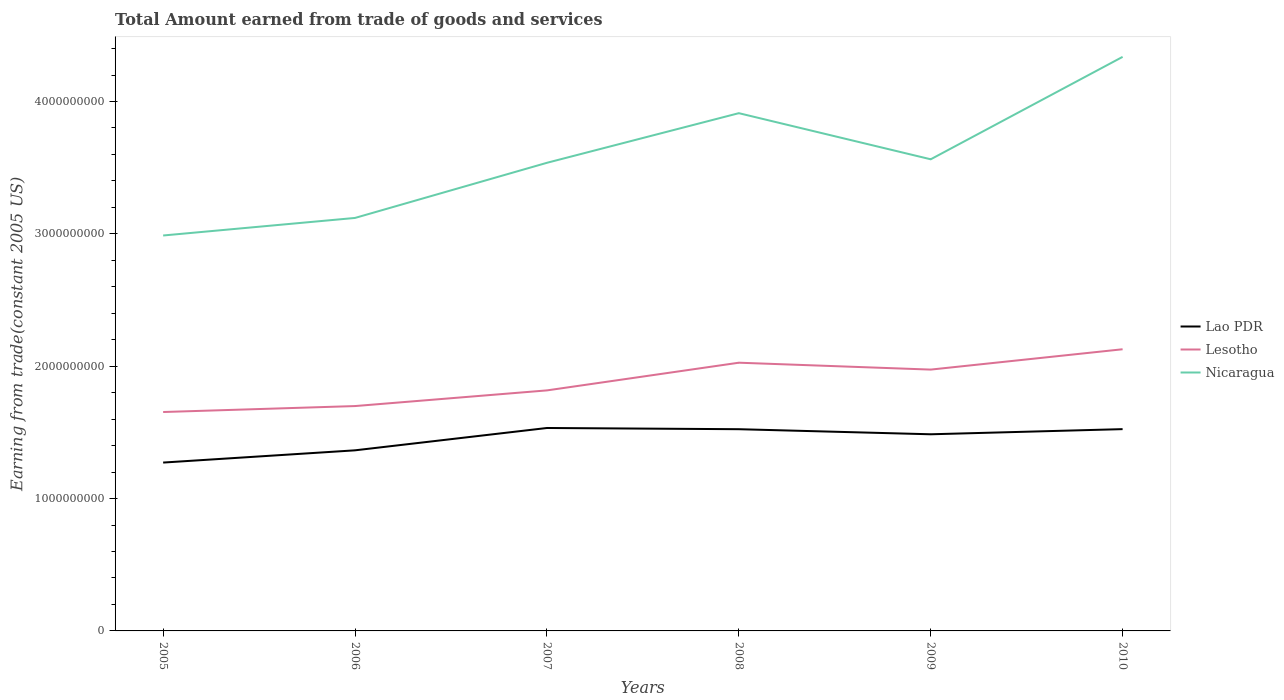Does the line corresponding to Lao PDR intersect with the line corresponding to Lesotho?
Your response must be concise. No. Across all years, what is the maximum total amount earned by trading goods and services in Lao PDR?
Your response must be concise. 1.27e+09. In which year was the total amount earned by trading goods and services in Nicaragua maximum?
Offer a terse response. 2005. What is the total total amount earned by trading goods and services in Nicaragua in the graph?
Provide a succinct answer. -9.24e+08. What is the difference between the highest and the second highest total amount earned by trading goods and services in Lao PDR?
Your response must be concise. 2.61e+08. What is the difference between the highest and the lowest total amount earned by trading goods and services in Lesotho?
Offer a terse response. 3. How many lines are there?
Offer a terse response. 3. What is the difference between two consecutive major ticks on the Y-axis?
Your response must be concise. 1.00e+09. Are the values on the major ticks of Y-axis written in scientific E-notation?
Ensure brevity in your answer.  No. Does the graph contain grids?
Your answer should be very brief. No. How are the legend labels stacked?
Your answer should be compact. Vertical. What is the title of the graph?
Offer a terse response. Total Amount earned from trade of goods and services. Does "Kenya" appear as one of the legend labels in the graph?
Your answer should be very brief. No. What is the label or title of the Y-axis?
Offer a very short reply. Earning from trade(constant 2005 US). What is the Earning from trade(constant 2005 US) in Lao PDR in 2005?
Provide a succinct answer. 1.27e+09. What is the Earning from trade(constant 2005 US) in Lesotho in 2005?
Offer a terse response. 1.65e+09. What is the Earning from trade(constant 2005 US) in Nicaragua in 2005?
Keep it short and to the point. 2.99e+09. What is the Earning from trade(constant 2005 US) of Lao PDR in 2006?
Your response must be concise. 1.36e+09. What is the Earning from trade(constant 2005 US) of Lesotho in 2006?
Your response must be concise. 1.70e+09. What is the Earning from trade(constant 2005 US) of Nicaragua in 2006?
Keep it short and to the point. 3.12e+09. What is the Earning from trade(constant 2005 US) of Lao PDR in 2007?
Your response must be concise. 1.53e+09. What is the Earning from trade(constant 2005 US) in Lesotho in 2007?
Offer a very short reply. 1.82e+09. What is the Earning from trade(constant 2005 US) in Nicaragua in 2007?
Make the answer very short. 3.54e+09. What is the Earning from trade(constant 2005 US) of Lao PDR in 2008?
Ensure brevity in your answer.  1.52e+09. What is the Earning from trade(constant 2005 US) of Lesotho in 2008?
Keep it short and to the point. 2.03e+09. What is the Earning from trade(constant 2005 US) of Nicaragua in 2008?
Give a very brief answer. 3.91e+09. What is the Earning from trade(constant 2005 US) of Lao PDR in 2009?
Your answer should be compact. 1.49e+09. What is the Earning from trade(constant 2005 US) in Lesotho in 2009?
Offer a very short reply. 1.97e+09. What is the Earning from trade(constant 2005 US) in Nicaragua in 2009?
Keep it short and to the point. 3.56e+09. What is the Earning from trade(constant 2005 US) in Lao PDR in 2010?
Your response must be concise. 1.52e+09. What is the Earning from trade(constant 2005 US) of Lesotho in 2010?
Offer a terse response. 2.13e+09. What is the Earning from trade(constant 2005 US) of Nicaragua in 2010?
Offer a very short reply. 4.34e+09. Across all years, what is the maximum Earning from trade(constant 2005 US) of Lao PDR?
Provide a succinct answer. 1.53e+09. Across all years, what is the maximum Earning from trade(constant 2005 US) of Lesotho?
Give a very brief answer. 2.13e+09. Across all years, what is the maximum Earning from trade(constant 2005 US) of Nicaragua?
Give a very brief answer. 4.34e+09. Across all years, what is the minimum Earning from trade(constant 2005 US) of Lao PDR?
Your answer should be compact. 1.27e+09. Across all years, what is the minimum Earning from trade(constant 2005 US) in Lesotho?
Make the answer very short. 1.65e+09. Across all years, what is the minimum Earning from trade(constant 2005 US) of Nicaragua?
Provide a succinct answer. 2.99e+09. What is the total Earning from trade(constant 2005 US) in Lao PDR in the graph?
Ensure brevity in your answer.  8.70e+09. What is the total Earning from trade(constant 2005 US) in Lesotho in the graph?
Offer a terse response. 1.13e+1. What is the total Earning from trade(constant 2005 US) in Nicaragua in the graph?
Make the answer very short. 2.15e+1. What is the difference between the Earning from trade(constant 2005 US) in Lao PDR in 2005 and that in 2006?
Provide a short and direct response. -9.25e+07. What is the difference between the Earning from trade(constant 2005 US) in Lesotho in 2005 and that in 2006?
Your answer should be compact. -4.50e+07. What is the difference between the Earning from trade(constant 2005 US) of Nicaragua in 2005 and that in 2006?
Keep it short and to the point. -1.33e+08. What is the difference between the Earning from trade(constant 2005 US) of Lao PDR in 2005 and that in 2007?
Give a very brief answer. -2.61e+08. What is the difference between the Earning from trade(constant 2005 US) in Lesotho in 2005 and that in 2007?
Provide a succinct answer. -1.63e+08. What is the difference between the Earning from trade(constant 2005 US) in Nicaragua in 2005 and that in 2007?
Offer a very short reply. -5.49e+08. What is the difference between the Earning from trade(constant 2005 US) in Lao PDR in 2005 and that in 2008?
Provide a succinct answer. -2.52e+08. What is the difference between the Earning from trade(constant 2005 US) in Lesotho in 2005 and that in 2008?
Provide a short and direct response. -3.73e+08. What is the difference between the Earning from trade(constant 2005 US) in Nicaragua in 2005 and that in 2008?
Your answer should be very brief. -9.24e+08. What is the difference between the Earning from trade(constant 2005 US) of Lao PDR in 2005 and that in 2009?
Ensure brevity in your answer.  -2.14e+08. What is the difference between the Earning from trade(constant 2005 US) in Lesotho in 2005 and that in 2009?
Your answer should be compact. -3.20e+08. What is the difference between the Earning from trade(constant 2005 US) of Nicaragua in 2005 and that in 2009?
Give a very brief answer. -5.76e+08. What is the difference between the Earning from trade(constant 2005 US) in Lao PDR in 2005 and that in 2010?
Make the answer very short. -2.53e+08. What is the difference between the Earning from trade(constant 2005 US) in Lesotho in 2005 and that in 2010?
Offer a very short reply. -4.74e+08. What is the difference between the Earning from trade(constant 2005 US) of Nicaragua in 2005 and that in 2010?
Offer a very short reply. -1.35e+09. What is the difference between the Earning from trade(constant 2005 US) in Lao PDR in 2006 and that in 2007?
Give a very brief answer. -1.69e+08. What is the difference between the Earning from trade(constant 2005 US) in Lesotho in 2006 and that in 2007?
Provide a short and direct response. -1.18e+08. What is the difference between the Earning from trade(constant 2005 US) of Nicaragua in 2006 and that in 2007?
Ensure brevity in your answer.  -4.17e+08. What is the difference between the Earning from trade(constant 2005 US) of Lao PDR in 2006 and that in 2008?
Provide a short and direct response. -1.60e+08. What is the difference between the Earning from trade(constant 2005 US) in Lesotho in 2006 and that in 2008?
Your answer should be compact. -3.28e+08. What is the difference between the Earning from trade(constant 2005 US) of Nicaragua in 2006 and that in 2008?
Give a very brief answer. -7.92e+08. What is the difference between the Earning from trade(constant 2005 US) in Lao PDR in 2006 and that in 2009?
Offer a very short reply. -1.21e+08. What is the difference between the Earning from trade(constant 2005 US) of Lesotho in 2006 and that in 2009?
Offer a terse response. -2.76e+08. What is the difference between the Earning from trade(constant 2005 US) of Nicaragua in 2006 and that in 2009?
Your answer should be very brief. -4.43e+08. What is the difference between the Earning from trade(constant 2005 US) of Lao PDR in 2006 and that in 2010?
Give a very brief answer. -1.60e+08. What is the difference between the Earning from trade(constant 2005 US) in Lesotho in 2006 and that in 2010?
Make the answer very short. -4.29e+08. What is the difference between the Earning from trade(constant 2005 US) in Nicaragua in 2006 and that in 2010?
Provide a short and direct response. -1.22e+09. What is the difference between the Earning from trade(constant 2005 US) of Lao PDR in 2007 and that in 2008?
Ensure brevity in your answer.  9.15e+06. What is the difference between the Earning from trade(constant 2005 US) of Lesotho in 2007 and that in 2008?
Keep it short and to the point. -2.09e+08. What is the difference between the Earning from trade(constant 2005 US) of Nicaragua in 2007 and that in 2008?
Your answer should be very brief. -3.75e+08. What is the difference between the Earning from trade(constant 2005 US) in Lao PDR in 2007 and that in 2009?
Offer a very short reply. 4.75e+07. What is the difference between the Earning from trade(constant 2005 US) of Lesotho in 2007 and that in 2009?
Provide a succinct answer. -1.57e+08. What is the difference between the Earning from trade(constant 2005 US) of Nicaragua in 2007 and that in 2009?
Provide a short and direct response. -2.65e+07. What is the difference between the Earning from trade(constant 2005 US) in Lao PDR in 2007 and that in 2010?
Provide a succinct answer. 8.63e+06. What is the difference between the Earning from trade(constant 2005 US) of Lesotho in 2007 and that in 2010?
Your answer should be compact. -3.11e+08. What is the difference between the Earning from trade(constant 2005 US) of Nicaragua in 2007 and that in 2010?
Your answer should be very brief. -8.00e+08. What is the difference between the Earning from trade(constant 2005 US) of Lao PDR in 2008 and that in 2009?
Your response must be concise. 3.84e+07. What is the difference between the Earning from trade(constant 2005 US) of Lesotho in 2008 and that in 2009?
Provide a succinct answer. 5.20e+07. What is the difference between the Earning from trade(constant 2005 US) of Nicaragua in 2008 and that in 2009?
Give a very brief answer. 3.48e+08. What is the difference between the Earning from trade(constant 2005 US) of Lao PDR in 2008 and that in 2010?
Give a very brief answer. -5.24e+05. What is the difference between the Earning from trade(constant 2005 US) in Lesotho in 2008 and that in 2010?
Give a very brief answer. -1.02e+08. What is the difference between the Earning from trade(constant 2005 US) in Nicaragua in 2008 and that in 2010?
Make the answer very short. -4.25e+08. What is the difference between the Earning from trade(constant 2005 US) of Lao PDR in 2009 and that in 2010?
Your answer should be compact. -3.89e+07. What is the difference between the Earning from trade(constant 2005 US) in Lesotho in 2009 and that in 2010?
Ensure brevity in your answer.  -1.54e+08. What is the difference between the Earning from trade(constant 2005 US) of Nicaragua in 2009 and that in 2010?
Keep it short and to the point. -7.74e+08. What is the difference between the Earning from trade(constant 2005 US) in Lao PDR in 2005 and the Earning from trade(constant 2005 US) in Lesotho in 2006?
Provide a short and direct response. -4.27e+08. What is the difference between the Earning from trade(constant 2005 US) in Lao PDR in 2005 and the Earning from trade(constant 2005 US) in Nicaragua in 2006?
Offer a terse response. -1.85e+09. What is the difference between the Earning from trade(constant 2005 US) in Lesotho in 2005 and the Earning from trade(constant 2005 US) in Nicaragua in 2006?
Give a very brief answer. -1.47e+09. What is the difference between the Earning from trade(constant 2005 US) of Lao PDR in 2005 and the Earning from trade(constant 2005 US) of Lesotho in 2007?
Offer a terse response. -5.45e+08. What is the difference between the Earning from trade(constant 2005 US) in Lao PDR in 2005 and the Earning from trade(constant 2005 US) in Nicaragua in 2007?
Make the answer very short. -2.26e+09. What is the difference between the Earning from trade(constant 2005 US) of Lesotho in 2005 and the Earning from trade(constant 2005 US) of Nicaragua in 2007?
Ensure brevity in your answer.  -1.88e+09. What is the difference between the Earning from trade(constant 2005 US) of Lao PDR in 2005 and the Earning from trade(constant 2005 US) of Lesotho in 2008?
Provide a short and direct response. -7.54e+08. What is the difference between the Earning from trade(constant 2005 US) of Lao PDR in 2005 and the Earning from trade(constant 2005 US) of Nicaragua in 2008?
Your answer should be compact. -2.64e+09. What is the difference between the Earning from trade(constant 2005 US) of Lesotho in 2005 and the Earning from trade(constant 2005 US) of Nicaragua in 2008?
Give a very brief answer. -2.26e+09. What is the difference between the Earning from trade(constant 2005 US) of Lao PDR in 2005 and the Earning from trade(constant 2005 US) of Lesotho in 2009?
Give a very brief answer. -7.02e+08. What is the difference between the Earning from trade(constant 2005 US) in Lao PDR in 2005 and the Earning from trade(constant 2005 US) in Nicaragua in 2009?
Your response must be concise. -2.29e+09. What is the difference between the Earning from trade(constant 2005 US) in Lesotho in 2005 and the Earning from trade(constant 2005 US) in Nicaragua in 2009?
Your answer should be very brief. -1.91e+09. What is the difference between the Earning from trade(constant 2005 US) in Lao PDR in 2005 and the Earning from trade(constant 2005 US) in Lesotho in 2010?
Your response must be concise. -8.56e+08. What is the difference between the Earning from trade(constant 2005 US) in Lao PDR in 2005 and the Earning from trade(constant 2005 US) in Nicaragua in 2010?
Your response must be concise. -3.07e+09. What is the difference between the Earning from trade(constant 2005 US) of Lesotho in 2005 and the Earning from trade(constant 2005 US) of Nicaragua in 2010?
Make the answer very short. -2.68e+09. What is the difference between the Earning from trade(constant 2005 US) in Lao PDR in 2006 and the Earning from trade(constant 2005 US) in Lesotho in 2007?
Provide a succinct answer. -4.53e+08. What is the difference between the Earning from trade(constant 2005 US) in Lao PDR in 2006 and the Earning from trade(constant 2005 US) in Nicaragua in 2007?
Offer a very short reply. -2.17e+09. What is the difference between the Earning from trade(constant 2005 US) in Lesotho in 2006 and the Earning from trade(constant 2005 US) in Nicaragua in 2007?
Provide a short and direct response. -1.84e+09. What is the difference between the Earning from trade(constant 2005 US) of Lao PDR in 2006 and the Earning from trade(constant 2005 US) of Lesotho in 2008?
Your answer should be compact. -6.62e+08. What is the difference between the Earning from trade(constant 2005 US) in Lao PDR in 2006 and the Earning from trade(constant 2005 US) in Nicaragua in 2008?
Your answer should be compact. -2.55e+09. What is the difference between the Earning from trade(constant 2005 US) of Lesotho in 2006 and the Earning from trade(constant 2005 US) of Nicaragua in 2008?
Ensure brevity in your answer.  -2.21e+09. What is the difference between the Earning from trade(constant 2005 US) of Lao PDR in 2006 and the Earning from trade(constant 2005 US) of Lesotho in 2009?
Give a very brief answer. -6.10e+08. What is the difference between the Earning from trade(constant 2005 US) in Lao PDR in 2006 and the Earning from trade(constant 2005 US) in Nicaragua in 2009?
Provide a succinct answer. -2.20e+09. What is the difference between the Earning from trade(constant 2005 US) of Lesotho in 2006 and the Earning from trade(constant 2005 US) of Nicaragua in 2009?
Your response must be concise. -1.86e+09. What is the difference between the Earning from trade(constant 2005 US) in Lao PDR in 2006 and the Earning from trade(constant 2005 US) in Lesotho in 2010?
Keep it short and to the point. -7.64e+08. What is the difference between the Earning from trade(constant 2005 US) of Lao PDR in 2006 and the Earning from trade(constant 2005 US) of Nicaragua in 2010?
Offer a very short reply. -2.97e+09. What is the difference between the Earning from trade(constant 2005 US) of Lesotho in 2006 and the Earning from trade(constant 2005 US) of Nicaragua in 2010?
Keep it short and to the point. -2.64e+09. What is the difference between the Earning from trade(constant 2005 US) of Lao PDR in 2007 and the Earning from trade(constant 2005 US) of Lesotho in 2008?
Make the answer very short. -4.93e+08. What is the difference between the Earning from trade(constant 2005 US) in Lao PDR in 2007 and the Earning from trade(constant 2005 US) in Nicaragua in 2008?
Your answer should be very brief. -2.38e+09. What is the difference between the Earning from trade(constant 2005 US) of Lesotho in 2007 and the Earning from trade(constant 2005 US) of Nicaragua in 2008?
Offer a terse response. -2.09e+09. What is the difference between the Earning from trade(constant 2005 US) of Lao PDR in 2007 and the Earning from trade(constant 2005 US) of Lesotho in 2009?
Provide a short and direct response. -4.41e+08. What is the difference between the Earning from trade(constant 2005 US) in Lao PDR in 2007 and the Earning from trade(constant 2005 US) in Nicaragua in 2009?
Offer a terse response. -2.03e+09. What is the difference between the Earning from trade(constant 2005 US) of Lesotho in 2007 and the Earning from trade(constant 2005 US) of Nicaragua in 2009?
Your answer should be compact. -1.75e+09. What is the difference between the Earning from trade(constant 2005 US) in Lao PDR in 2007 and the Earning from trade(constant 2005 US) in Lesotho in 2010?
Give a very brief answer. -5.95e+08. What is the difference between the Earning from trade(constant 2005 US) of Lao PDR in 2007 and the Earning from trade(constant 2005 US) of Nicaragua in 2010?
Offer a very short reply. -2.80e+09. What is the difference between the Earning from trade(constant 2005 US) of Lesotho in 2007 and the Earning from trade(constant 2005 US) of Nicaragua in 2010?
Keep it short and to the point. -2.52e+09. What is the difference between the Earning from trade(constant 2005 US) of Lao PDR in 2008 and the Earning from trade(constant 2005 US) of Lesotho in 2009?
Keep it short and to the point. -4.50e+08. What is the difference between the Earning from trade(constant 2005 US) in Lao PDR in 2008 and the Earning from trade(constant 2005 US) in Nicaragua in 2009?
Make the answer very short. -2.04e+09. What is the difference between the Earning from trade(constant 2005 US) in Lesotho in 2008 and the Earning from trade(constant 2005 US) in Nicaragua in 2009?
Keep it short and to the point. -1.54e+09. What is the difference between the Earning from trade(constant 2005 US) in Lao PDR in 2008 and the Earning from trade(constant 2005 US) in Lesotho in 2010?
Provide a succinct answer. -6.04e+08. What is the difference between the Earning from trade(constant 2005 US) in Lao PDR in 2008 and the Earning from trade(constant 2005 US) in Nicaragua in 2010?
Make the answer very short. -2.81e+09. What is the difference between the Earning from trade(constant 2005 US) of Lesotho in 2008 and the Earning from trade(constant 2005 US) of Nicaragua in 2010?
Ensure brevity in your answer.  -2.31e+09. What is the difference between the Earning from trade(constant 2005 US) of Lao PDR in 2009 and the Earning from trade(constant 2005 US) of Lesotho in 2010?
Offer a terse response. -6.42e+08. What is the difference between the Earning from trade(constant 2005 US) in Lao PDR in 2009 and the Earning from trade(constant 2005 US) in Nicaragua in 2010?
Provide a short and direct response. -2.85e+09. What is the difference between the Earning from trade(constant 2005 US) of Lesotho in 2009 and the Earning from trade(constant 2005 US) of Nicaragua in 2010?
Your answer should be compact. -2.36e+09. What is the average Earning from trade(constant 2005 US) of Lao PDR per year?
Make the answer very short. 1.45e+09. What is the average Earning from trade(constant 2005 US) of Lesotho per year?
Keep it short and to the point. 1.88e+09. What is the average Earning from trade(constant 2005 US) of Nicaragua per year?
Provide a succinct answer. 3.58e+09. In the year 2005, what is the difference between the Earning from trade(constant 2005 US) in Lao PDR and Earning from trade(constant 2005 US) in Lesotho?
Ensure brevity in your answer.  -3.82e+08. In the year 2005, what is the difference between the Earning from trade(constant 2005 US) of Lao PDR and Earning from trade(constant 2005 US) of Nicaragua?
Keep it short and to the point. -1.72e+09. In the year 2005, what is the difference between the Earning from trade(constant 2005 US) in Lesotho and Earning from trade(constant 2005 US) in Nicaragua?
Provide a short and direct response. -1.33e+09. In the year 2006, what is the difference between the Earning from trade(constant 2005 US) in Lao PDR and Earning from trade(constant 2005 US) in Lesotho?
Offer a terse response. -3.34e+08. In the year 2006, what is the difference between the Earning from trade(constant 2005 US) in Lao PDR and Earning from trade(constant 2005 US) in Nicaragua?
Ensure brevity in your answer.  -1.76e+09. In the year 2006, what is the difference between the Earning from trade(constant 2005 US) of Lesotho and Earning from trade(constant 2005 US) of Nicaragua?
Provide a short and direct response. -1.42e+09. In the year 2007, what is the difference between the Earning from trade(constant 2005 US) of Lao PDR and Earning from trade(constant 2005 US) of Lesotho?
Provide a succinct answer. -2.84e+08. In the year 2007, what is the difference between the Earning from trade(constant 2005 US) of Lao PDR and Earning from trade(constant 2005 US) of Nicaragua?
Your response must be concise. -2.00e+09. In the year 2007, what is the difference between the Earning from trade(constant 2005 US) in Lesotho and Earning from trade(constant 2005 US) in Nicaragua?
Offer a terse response. -1.72e+09. In the year 2008, what is the difference between the Earning from trade(constant 2005 US) of Lao PDR and Earning from trade(constant 2005 US) of Lesotho?
Your answer should be compact. -5.02e+08. In the year 2008, what is the difference between the Earning from trade(constant 2005 US) of Lao PDR and Earning from trade(constant 2005 US) of Nicaragua?
Ensure brevity in your answer.  -2.39e+09. In the year 2008, what is the difference between the Earning from trade(constant 2005 US) of Lesotho and Earning from trade(constant 2005 US) of Nicaragua?
Your answer should be compact. -1.89e+09. In the year 2009, what is the difference between the Earning from trade(constant 2005 US) of Lao PDR and Earning from trade(constant 2005 US) of Lesotho?
Your response must be concise. -4.89e+08. In the year 2009, what is the difference between the Earning from trade(constant 2005 US) of Lao PDR and Earning from trade(constant 2005 US) of Nicaragua?
Your answer should be very brief. -2.08e+09. In the year 2009, what is the difference between the Earning from trade(constant 2005 US) in Lesotho and Earning from trade(constant 2005 US) in Nicaragua?
Provide a succinct answer. -1.59e+09. In the year 2010, what is the difference between the Earning from trade(constant 2005 US) in Lao PDR and Earning from trade(constant 2005 US) in Lesotho?
Give a very brief answer. -6.03e+08. In the year 2010, what is the difference between the Earning from trade(constant 2005 US) in Lao PDR and Earning from trade(constant 2005 US) in Nicaragua?
Your response must be concise. -2.81e+09. In the year 2010, what is the difference between the Earning from trade(constant 2005 US) in Lesotho and Earning from trade(constant 2005 US) in Nicaragua?
Your response must be concise. -2.21e+09. What is the ratio of the Earning from trade(constant 2005 US) in Lao PDR in 2005 to that in 2006?
Your answer should be compact. 0.93. What is the ratio of the Earning from trade(constant 2005 US) of Lesotho in 2005 to that in 2006?
Make the answer very short. 0.97. What is the ratio of the Earning from trade(constant 2005 US) of Nicaragua in 2005 to that in 2006?
Provide a succinct answer. 0.96. What is the ratio of the Earning from trade(constant 2005 US) of Lao PDR in 2005 to that in 2007?
Provide a succinct answer. 0.83. What is the ratio of the Earning from trade(constant 2005 US) of Lesotho in 2005 to that in 2007?
Your answer should be very brief. 0.91. What is the ratio of the Earning from trade(constant 2005 US) of Nicaragua in 2005 to that in 2007?
Your answer should be very brief. 0.84. What is the ratio of the Earning from trade(constant 2005 US) of Lao PDR in 2005 to that in 2008?
Offer a very short reply. 0.83. What is the ratio of the Earning from trade(constant 2005 US) of Lesotho in 2005 to that in 2008?
Offer a very short reply. 0.82. What is the ratio of the Earning from trade(constant 2005 US) in Nicaragua in 2005 to that in 2008?
Offer a very short reply. 0.76. What is the ratio of the Earning from trade(constant 2005 US) of Lao PDR in 2005 to that in 2009?
Give a very brief answer. 0.86. What is the ratio of the Earning from trade(constant 2005 US) of Lesotho in 2005 to that in 2009?
Your answer should be compact. 0.84. What is the ratio of the Earning from trade(constant 2005 US) of Nicaragua in 2005 to that in 2009?
Keep it short and to the point. 0.84. What is the ratio of the Earning from trade(constant 2005 US) in Lao PDR in 2005 to that in 2010?
Provide a succinct answer. 0.83. What is the ratio of the Earning from trade(constant 2005 US) of Lesotho in 2005 to that in 2010?
Offer a terse response. 0.78. What is the ratio of the Earning from trade(constant 2005 US) in Nicaragua in 2005 to that in 2010?
Your answer should be compact. 0.69. What is the ratio of the Earning from trade(constant 2005 US) of Lao PDR in 2006 to that in 2007?
Provide a succinct answer. 0.89. What is the ratio of the Earning from trade(constant 2005 US) of Lesotho in 2006 to that in 2007?
Make the answer very short. 0.93. What is the ratio of the Earning from trade(constant 2005 US) of Nicaragua in 2006 to that in 2007?
Offer a very short reply. 0.88. What is the ratio of the Earning from trade(constant 2005 US) in Lao PDR in 2006 to that in 2008?
Make the answer very short. 0.9. What is the ratio of the Earning from trade(constant 2005 US) in Lesotho in 2006 to that in 2008?
Offer a very short reply. 0.84. What is the ratio of the Earning from trade(constant 2005 US) of Nicaragua in 2006 to that in 2008?
Offer a very short reply. 0.8. What is the ratio of the Earning from trade(constant 2005 US) in Lao PDR in 2006 to that in 2009?
Keep it short and to the point. 0.92. What is the ratio of the Earning from trade(constant 2005 US) in Lesotho in 2006 to that in 2009?
Offer a terse response. 0.86. What is the ratio of the Earning from trade(constant 2005 US) in Nicaragua in 2006 to that in 2009?
Your response must be concise. 0.88. What is the ratio of the Earning from trade(constant 2005 US) in Lao PDR in 2006 to that in 2010?
Offer a very short reply. 0.9. What is the ratio of the Earning from trade(constant 2005 US) of Lesotho in 2006 to that in 2010?
Ensure brevity in your answer.  0.8. What is the ratio of the Earning from trade(constant 2005 US) of Nicaragua in 2006 to that in 2010?
Provide a succinct answer. 0.72. What is the ratio of the Earning from trade(constant 2005 US) of Lao PDR in 2007 to that in 2008?
Your answer should be compact. 1.01. What is the ratio of the Earning from trade(constant 2005 US) of Lesotho in 2007 to that in 2008?
Your response must be concise. 0.9. What is the ratio of the Earning from trade(constant 2005 US) of Nicaragua in 2007 to that in 2008?
Offer a terse response. 0.9. What is the ratio of the Earning from trade(constant 2005 US) in Lao PDR in 2007 to that in 2009?
Offer a very short reply. 1.03. What is the ratio of the Earning from trade(constant 2005 US) in Lesotho in 2007 to that in 2009?
Provide a short and direct response. 0.92. What is the ratio of the Earning from trade(constant 2005 US) in Nicaragua in 2007 to that in 2009?
Offer a very short reply. 0.99. What is the ratio of the Earning from trade(constant 2005 US) in Lesotho in 2007 to that in 2010?
Provide a succinct answer. 0.85. What is the ratio of the Earning from trade(constant 2005 US) of Nicaragua in 2007 to that in 2010?
Keep it short and to the point. 0.82. What is the ratio of the Earning from trade(constant 2005 US) of Lao PDR in 2008 to that in 2009?
Offer a very short reply. 1.03. What is the ratio of the Earning from trade(constant 2005 US) of Lesotho in 2008 to that in 2009?
Your answer should be very brief. 1.03. What is the ratio of the Earning from trade(constant 2005 US) of Nicaragua in 2008 to that in 2009?
Keep it short and to the point. 1.1. What is the ratio of the Earning from trade(constant 2005 US) in Lao PDR in 2008 to that in 2010?
Your answer should be very brief. 1. What is the ratio of the Earning from trade(constant 2005 US) in Lesotho in 2008 to that in 2010?
Your answer should be very brief. 0.95. What is the ratio of the Earning from trade(constant 2005 US) of Nicaragua in 2008 to that in 2010?
Keep it short and to the point. 0.9. What is the ratio of the Earning from trade(constant 2005 US) of Lao PDR in 2009 to that in 2010?
Provide a succinct answer. 0.97. What is the ratio of the Earning from trade(constant 2005 US) in Lesotho in 2009 to that in 2010?
Keep it short and to the point. 0.93. What is the ratio of the Earning from trade(constant 2005 US) of Nicaragua in 2009 to that in 2010?
Give a very brief answer. 0.82. What is the difference between the highest and the second highest Earning from trade(constant 2005 US) in Lao PDR?
Make the answer very short. 8.63e+06. What is the difference between the highest and the second highest Earning from trade(constant 2005 US) in Lesotho?
Offer a very short reply. 1.02e+08. What is the difference between the highest and the second highest Earning from trade(constant 2005 US) of Nicaragua?
Your response must be concise. 4.25e+08. What is the difference between the highest and the lowest Earning from trade(constant 2005 US) in Lao PDR?
Your answer should be compact. 2.61e+08. What is the difference between the highest and the lowest Earning from trade(constant 2005 US) in Lesotho?
Your response must be concise. 4.74e+08. What is the difference between the highest and the lowest Earning from trade(constant 2005 US) of Nicaragua?
Offer a terse response. 1.35e+09. 